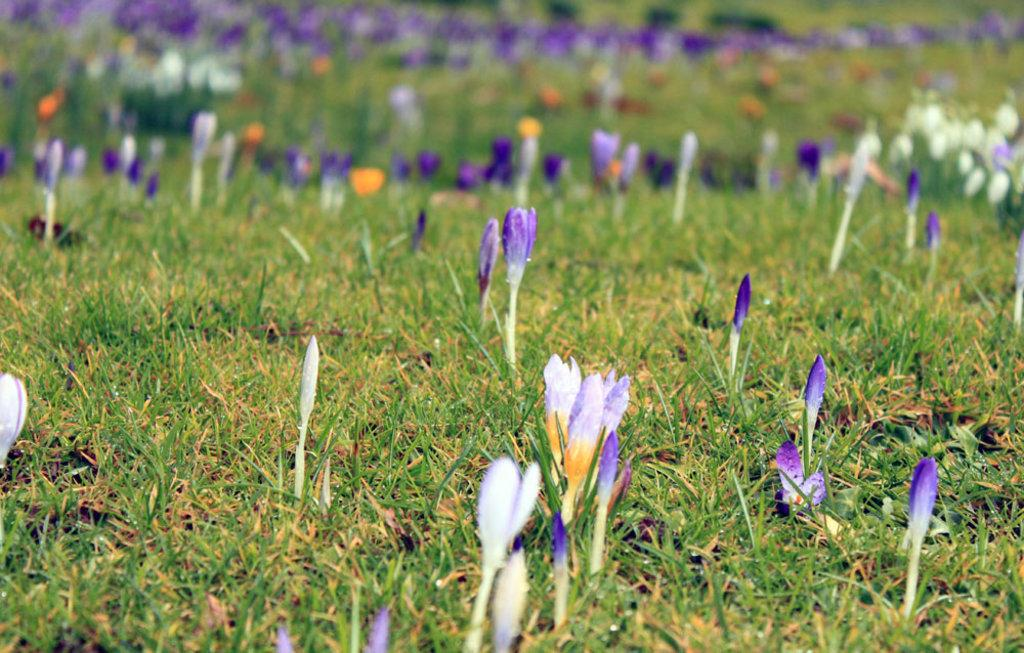What type of vegetation can be seen in the image? There is grass in the image. What else can be found on the ground in the image? There are flowers on the ground in the image. What arithmetic problem is being solved by the flowers in the image? There is no arithmetic problem being solved by the flowers in the image, as flowers do not have the ability to solve mathematical problems. 